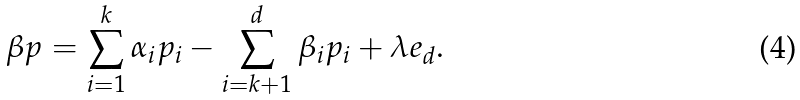Convert formula to latex. <formula><loc_0><loc_0><loc_500><loc_500>\beta p = \sum _ { i = 1 } ^ { k } \alpha _ { i } p _ { i } - \sum _ { i = k + 1 } ^ { d } \beta _ { i } p _ { i } + \lambda e _ { d } .</formula> 